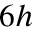<formula> <loc_0><loc_0><loc_500><loc_500>6 h</formula> 